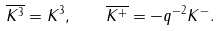Convert formula to latex. <formula><loc_0><loc_0><loc_500><loc_500>\overline { K ^ { 3 } } = K ^ { 3 } , \quad \overline { K ^ { + } } = - q ^ { - 2 } K ^ { - } .</formula> 